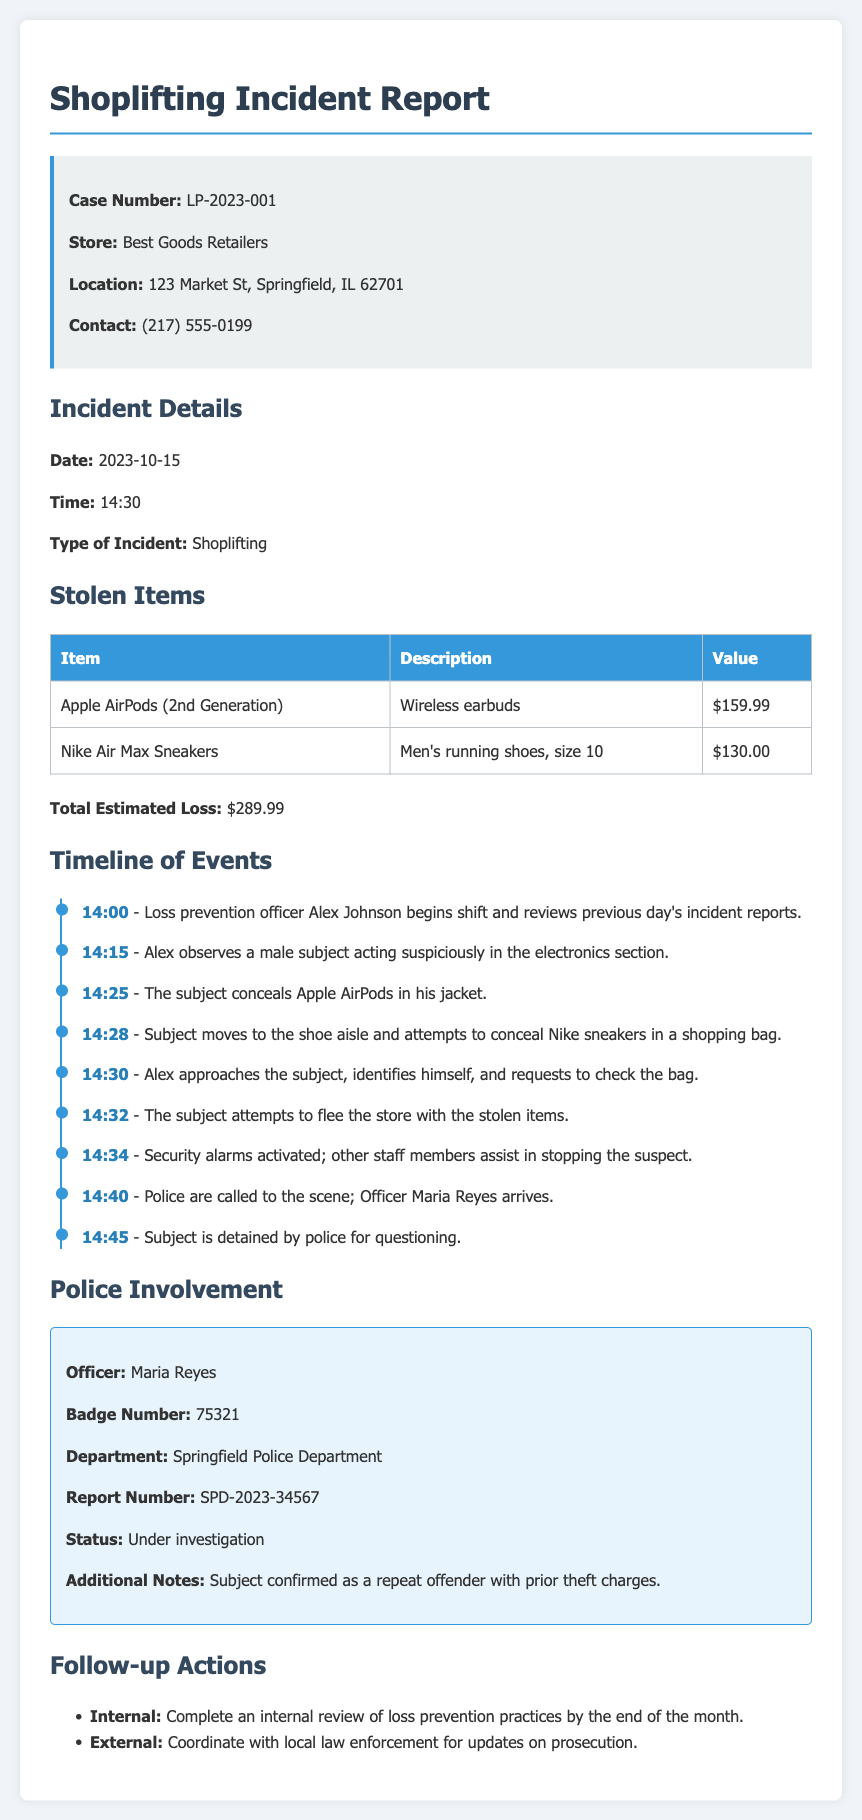What is the case number? The case number is listed at the top of the incident report as LP-2023-001.
Answer: LP-2023-001 What is the total estimated loss? The total estimated loss is calculated by adding the values of the stolen items, which is $289.99.
Answer: $289.99 Who is the loss prevention officer? The loss prevention officer's name is mentioned in the timeline of events as Alex Johnson.
Answer: Alex Johnson At what time did the police arrive? The incident report specifies that the police arrived at 14:40.
Answer: 14:40 What items were stolen? The stolen items listed are Apple AirPods (2nd Generation) and Nike Air Max Sneakers.
Answer: Apple AirPods (2nd Generation) and Nike Air Max Sneakers What is the status of the police investigation? The report indicates that the status of the investigation is "Under investigation."
Answer: Under investigation What is the badge number of the police officer involved? The badge number for Officer Maria Reyes is stated as 75321.
Answer: 75321 What follow-up action is specified for internal review? The internal follow-up action stated is to complete a review of loss prevention practices by the end of the month.
Answer: Complete an internal review of loss prevention practices by the end of the month How long before the subject attempted to flee after identification? The subject attempted to flee 2 minutes after the loss prevention officer identified himself at 14:30.
Answer: 2 minutes 